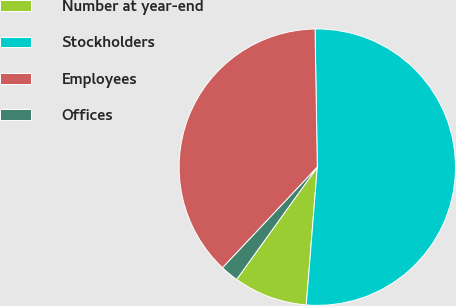Convert chart. <chart><loc_0><loc_0><loc_500><loc_500><pie_chart><fcel>Number at year-end<fcel>Stockholders<fcel>Employees<fcel>Offices<nl><fcel>8.64%<fcel>51.54%<fcel>37.72%<fcel>2.11%<nl></chart> 